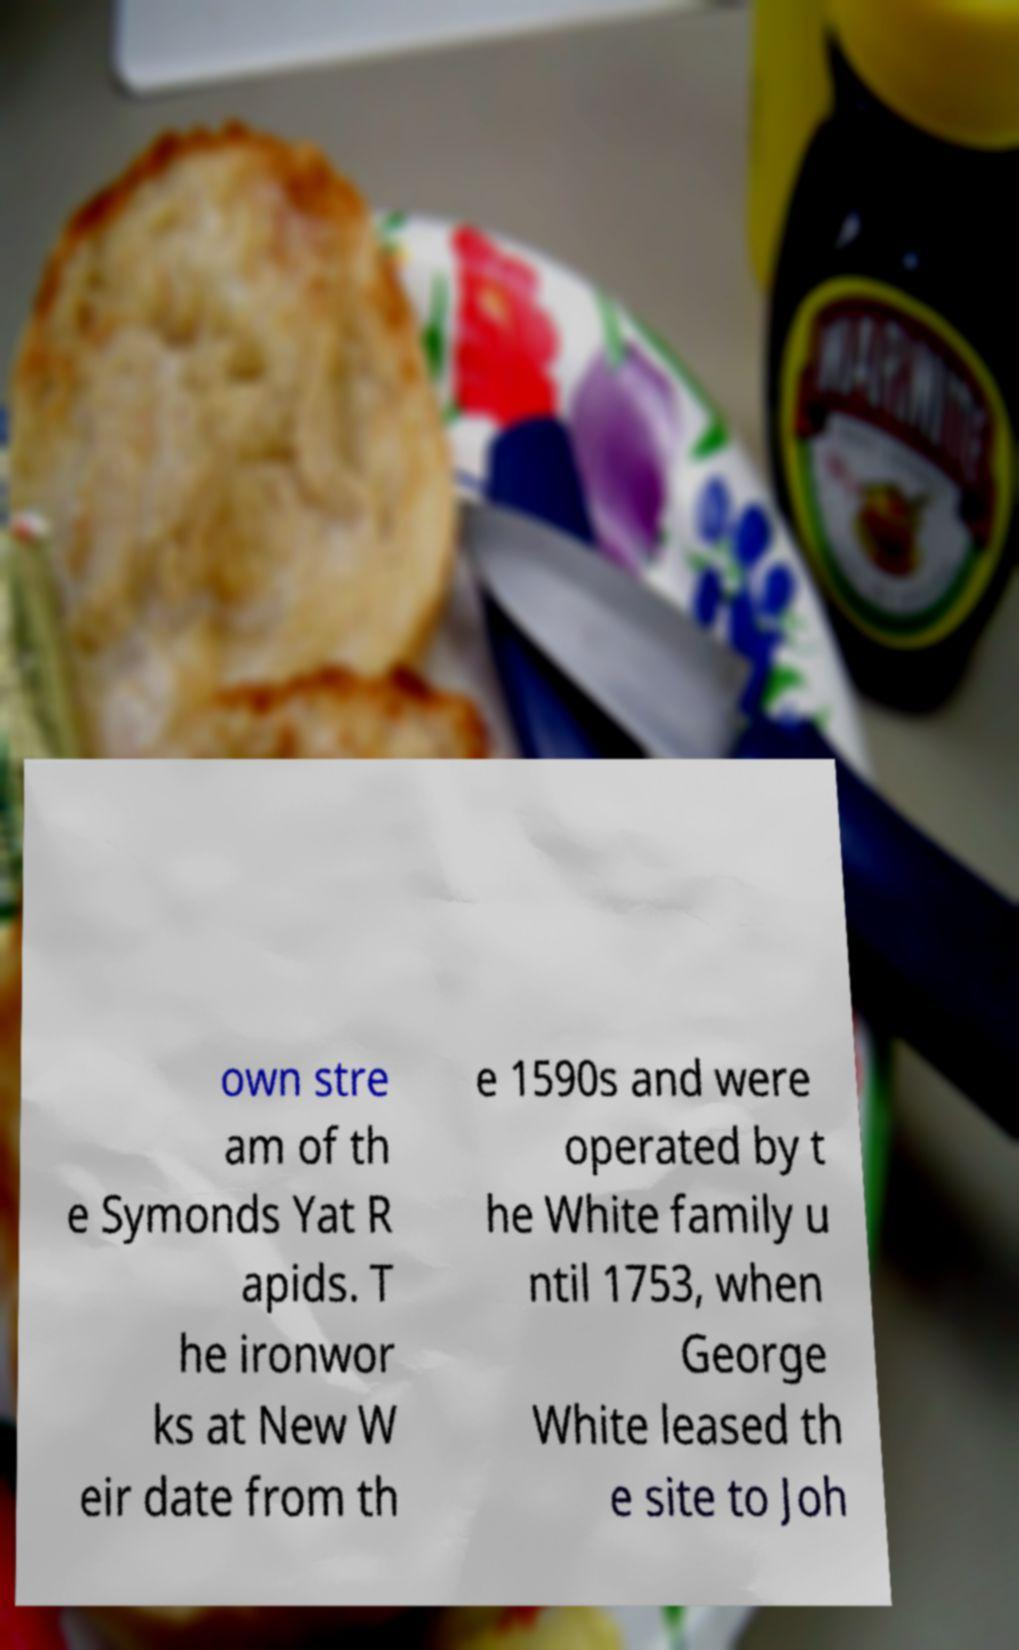Can you read and provide the text displayed in the image?This photo seems to have some interesting text. Can you extract and type it out for me? own stre am of th e Symonds Yat R apids. T he ironwor ks at New W eir date from th e 1590s and were operated by t he White family u ntil 1753, when George White leased th e site to Joh 